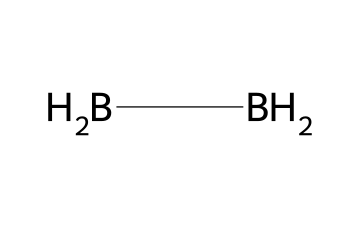What is the molecular formula of diborane? The SMILES notation [BH2][BH2] indicates that diborane consists of two boron atoms and four hydrogen atoms. Therefore, the molecular formula is derived from counting these atoms: B2H6.
Answer: B2H6 How many hydrogen atoms are present in diborane? The SMILES notation shows that each boron atom is connected to two hydrogen atoms, leading to a total of four hydrogen atoms in the structure.
Answer: four What is the hybridization of boron in diborane? Due to the presence of three centered bonds and one bridging hydrogen atom, the boron atoms undergo sp3 hybridization, which is typical for compounds featuring four regions of electron density.
Answer: sp3 Why is diborane considered a flammable gas? The structure of diborane contains hydrogen atoms that can readily combust in the presence of oxygen, producing heat and energy. The presence of two boron atoms also supports combustion reactions, contributing to its flammability.
Answer: flammable How many covalent bonds are present in diborane? In the structure, each boron atom is attached to two hydrogen atoms, and the bonding exists between the boron and hydrogen atoms. There are a total of six covalent bonds: two between each boron and hydrogen, plus two additional bridge bonds between the boron atoms.
Answer: six What type of chemical compound is diborane classified as? Diborane contains boron and hydrogen, placing it in the category of boranes, which specifically refers to compounds consisting mainly of boron-hydrogen bonds.
Answer: borane 